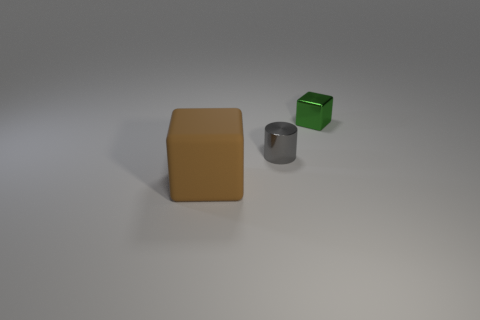Add 2 big cylinders. How many objects exist? 5 Subtract all blocks. How many objects are left? 1 Subtract all green balls. Subtract all green metal cubes. How many objects are left? 2 Add 1 big rubber objects. How many big rubber objects are left? 2 Add 1 small cyan shiny spheres. How many small cyan shiny spheres exist? 1 Subtract 0 red cylinders. How many objects are left? 3 